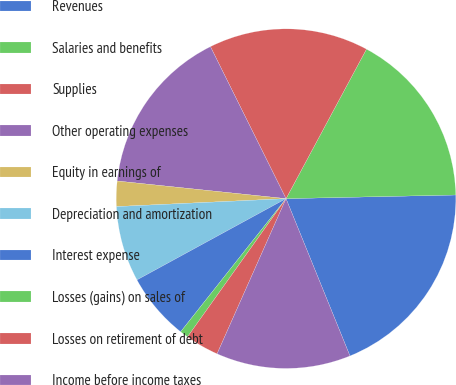Convert chart. <chart><loc_0><loc_0><loc_500><loc_500><pie_chart><fcel>Revenues<fcel>Salaries and benefits<fcel>Supplies<fcel>Other operating expenses<fcel>Equity in earnings of<fcel>Depreciation and amortization<fcel>Interest expense<fcel>Losses (gains) on sales of<fcel>Losses on retirement of debt<fcel>Income before income taxes<nl><fcel>19.2%<fcel>16.8%<fcel>15.2%<fcel>16.0%<fcel>2.4%<fcel>7.2%<fcel>6.4%<fcel>0.8%<fcel>3.2%<fcel>12.8%<nl></chart> 